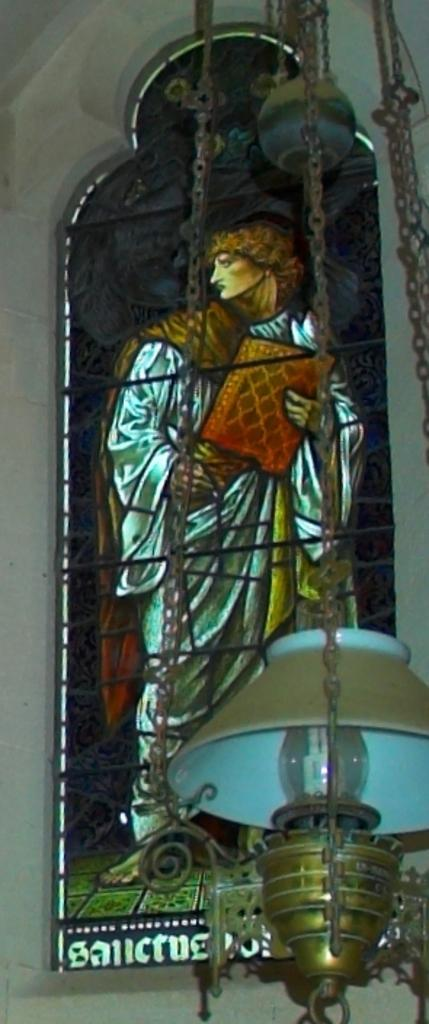What type of glass is featured in the image? There is a stained glass in the image. What type of lighting fixture is present in the image? There is a chandelier in the image. What can be seen in the background of the image? There is a wall in the background of the image. How many pies are displayed on the stained glass in the image? There are no pies present on the stained glass in the image. What type of neck accessory is worn by the chandelier in the image? There is no neck accessory worn by the chandelier in the image, as it is a lighting fixture and not a person. 